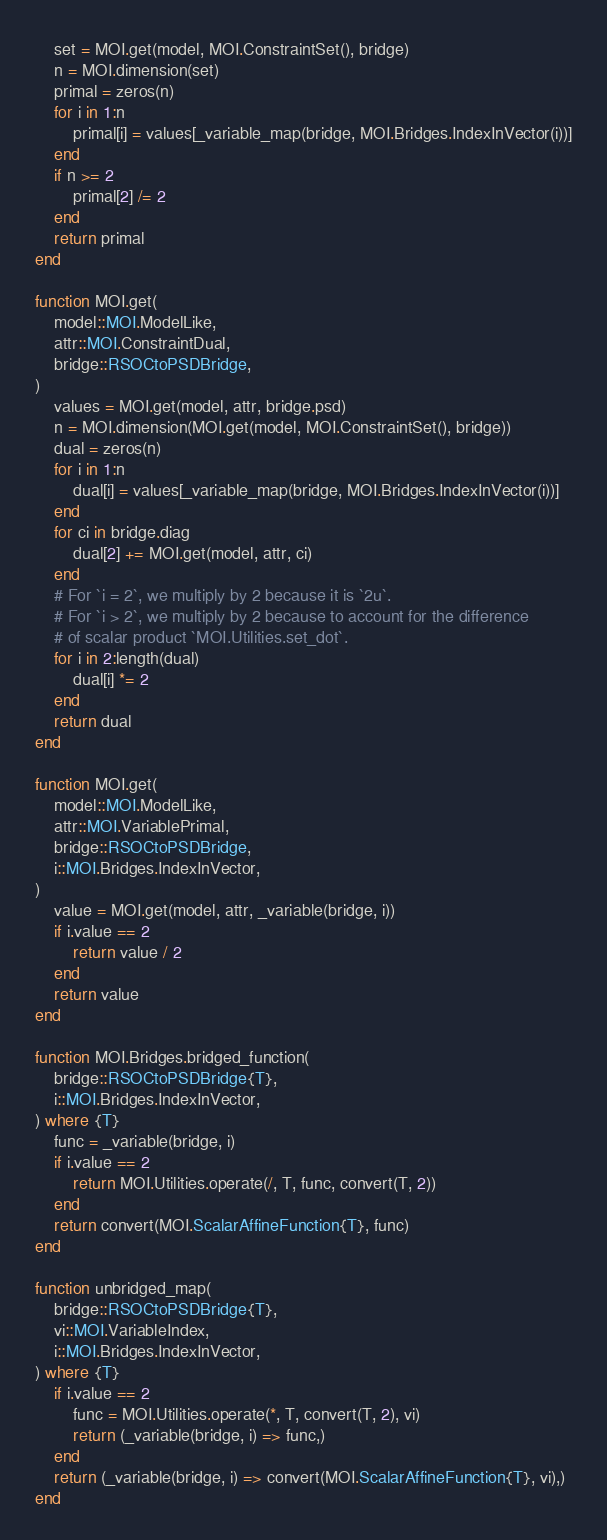<code> <loc_0><loc_0><loc_500><loc_500><_Julia_>    set = MOI.get(model, MOI.ConstraintSet(), bridge)
    n = MOI.dimension(set)
    primal = zeros(n)
    for i in 1:n
        primal[i] = values[_variable_map(bridge, MOI.Bridges.IndexInVector(i))]
    end
    if n >= 2
        primal[2] /= 2
    end
    return primal
end

function MOI.get(
    model::MOI.ModelLike,
    attr::MOI.ConstraintDual,
    bridge::RSOCtoPSDBridge,
)
    values = MOI.get(model, attr, bridge.psd)
    n = MOI.dimension(MOI.get(model, MOI.ConstraintSet(), bridge))
    dual = zeros(n)
    for i in 1:n
        dual[i] = values[_variable_map(bridge, MOI.Bridges.IndexInVector(i))]
    end
    for ci in bridge.diag
        dual[2] += MOI.get(model, attr, ci)
    end
    # For `i = 2`, we multiply by 2 because it is `2u`.
    # For `i > 2`, we multiply by 2 because to account for the difference
    # of scalar product `MOI.Utilities.set_dot`.
    for i in 2:length(dual)
        dual[i] *= 2
    end
    return dual
end

function MOI.get(
    model::MOI.ModelLike,
    attr::MOI.VariablePrimal,
    bridge::RSOCtoPSDBridge,
    i::MOI.Bridges.IndexInVector,
)
    value = MOI.get(model, attr, _variable(bridge, i))
    if i.value == 2
        return value / 2
    end
    return value
end

function MOI.Bridges.bridged_function(
    bridge::RSOCtoPSDBridge{T},
    i::MOI.Bridges.IndexInVector,
) where {T}
    func = _variable(bridge, i)
    if i.value == 2
        return MOI.Utilities.operate(/, T, func, convert(T, 2))
    end
    return convert(MOI.ScalarAffineFunction{T}, func)
end

function unbridged_map(
    bridge::RSOCtoPSDBridge{T},
    vi::MOI.VariableIndex,
    i::MOI.Bridges.IndexInVector,
) where {T}
    if i.value == 2
        func = MOI.Utilities.operate(*, T, convert(T, 2), vi)
        return (_variable(bridge, i) => func,)
    end
    return (_variable(bridge, i) => convert(MOI.ScalarAffineFunction{T}, vi),)
end
</code> 